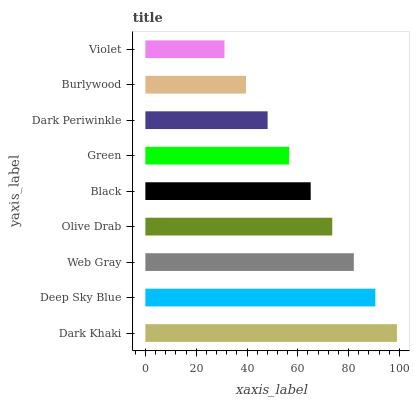Is Violet the minimum?
Answer yes or no. Yes. Is Dark Khaki the maximum?
Answer yes or no. Yes. Is Deep Sky Blue the minimum?
Answer yes or no. No. Is Deep Sky Blue the maximum?
Answer yes or no. No. Is Dark Khaki greater than Deep Sky Blue?
Answer yes or no. Yes. Is Deep Sky Blue less than Dark Khaki?
Answer yes or no. Yes. Is Deep Sky Blue greater than Dark Khaki?
Answer yes or no. No. Is Dark Khaki less than Deep Sky Blue?
Answer yes or no. No. Is Black the high median?
Answer yes or no. Yes. Is Black the low median?
Answer yes or no. Yes. Is Burlywood the high median?
Answer yes or no. No. Is Deep Sky Blue the low median?
Answer yes or no. No. 